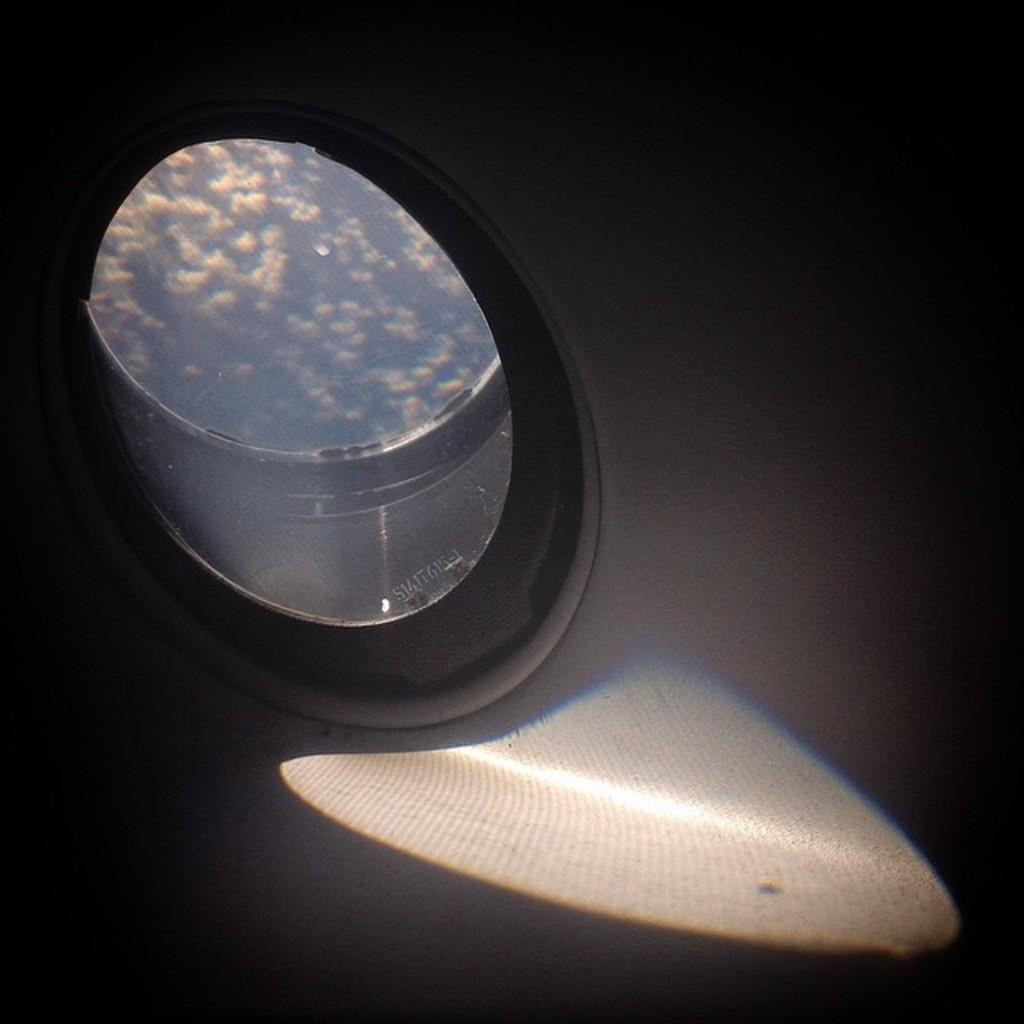What type of structure is present in the image? There is a glass window in the image. What can be seen through the glass window? Clouds are visible through the glass window. Is there a basketball game happening outside the window in the image? There is no basketball game visible in the image; only clouds can be seen through the glass window. 